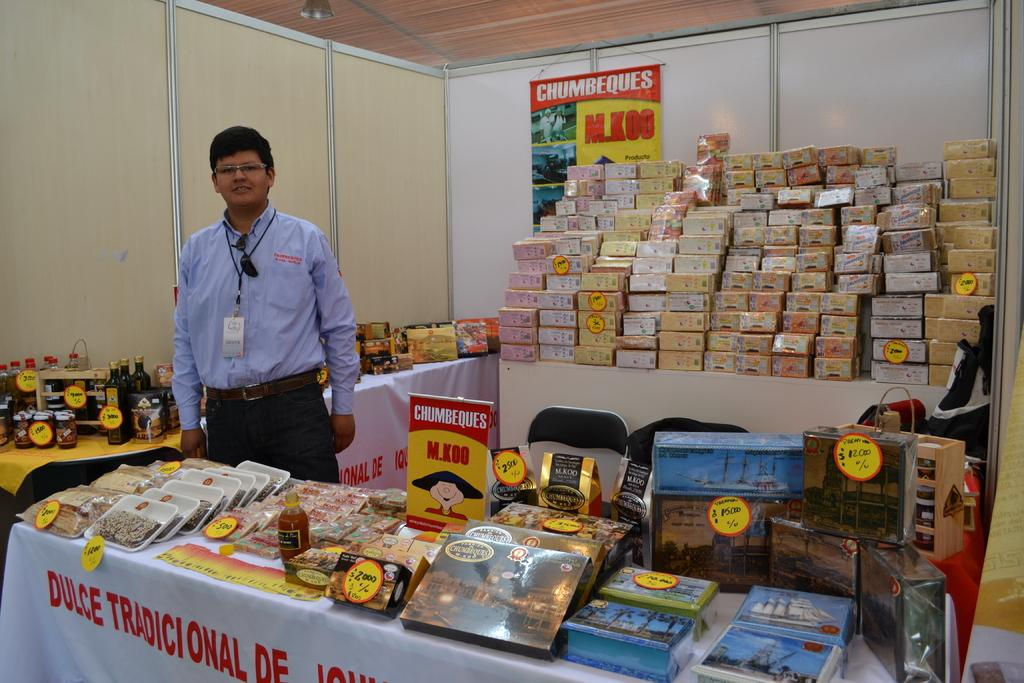<image>
Create a compact narrative representing the image presented. A vendor displaying products on tables near a chumbeques sign. 